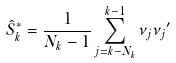<formula> <loc_0><loc_0><loc_500><loc_500>\hat { S } _ { k } ^ { * } = \frac { 1 } { N _ { k } - 1 } \sum _ { j = k - N _ { k } } ^ { k - 1 } { \nu _ { j } { \nu _ { j } } ^ { \prime } }</formula> 